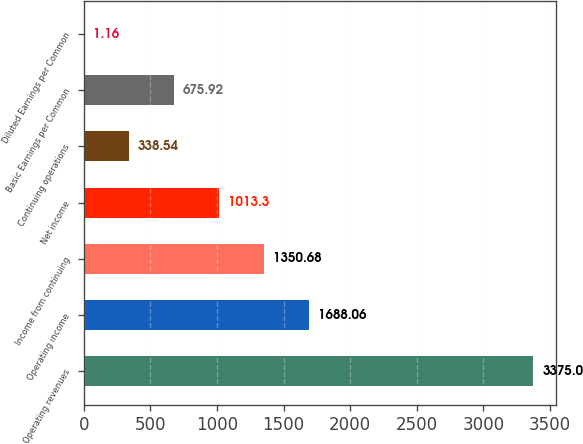Convert chart to OTSL. <chart><loc_0><loc_0><loc_500><loc_500><bar_chart><fcel>Operating revenues<fcel>Operating income<fcel>Income from continuing<fcel>Net income<fcel>Continuing operations<fcel>Basic Earnings per Common<fcel>Diluted Earnings per Common<nl><fcel>3375<fcel>1688.06<fcel>1350.68<fcel>1013.3<fcel>338.54<fcel>675.92<fcel>1.16<nl></chart> 